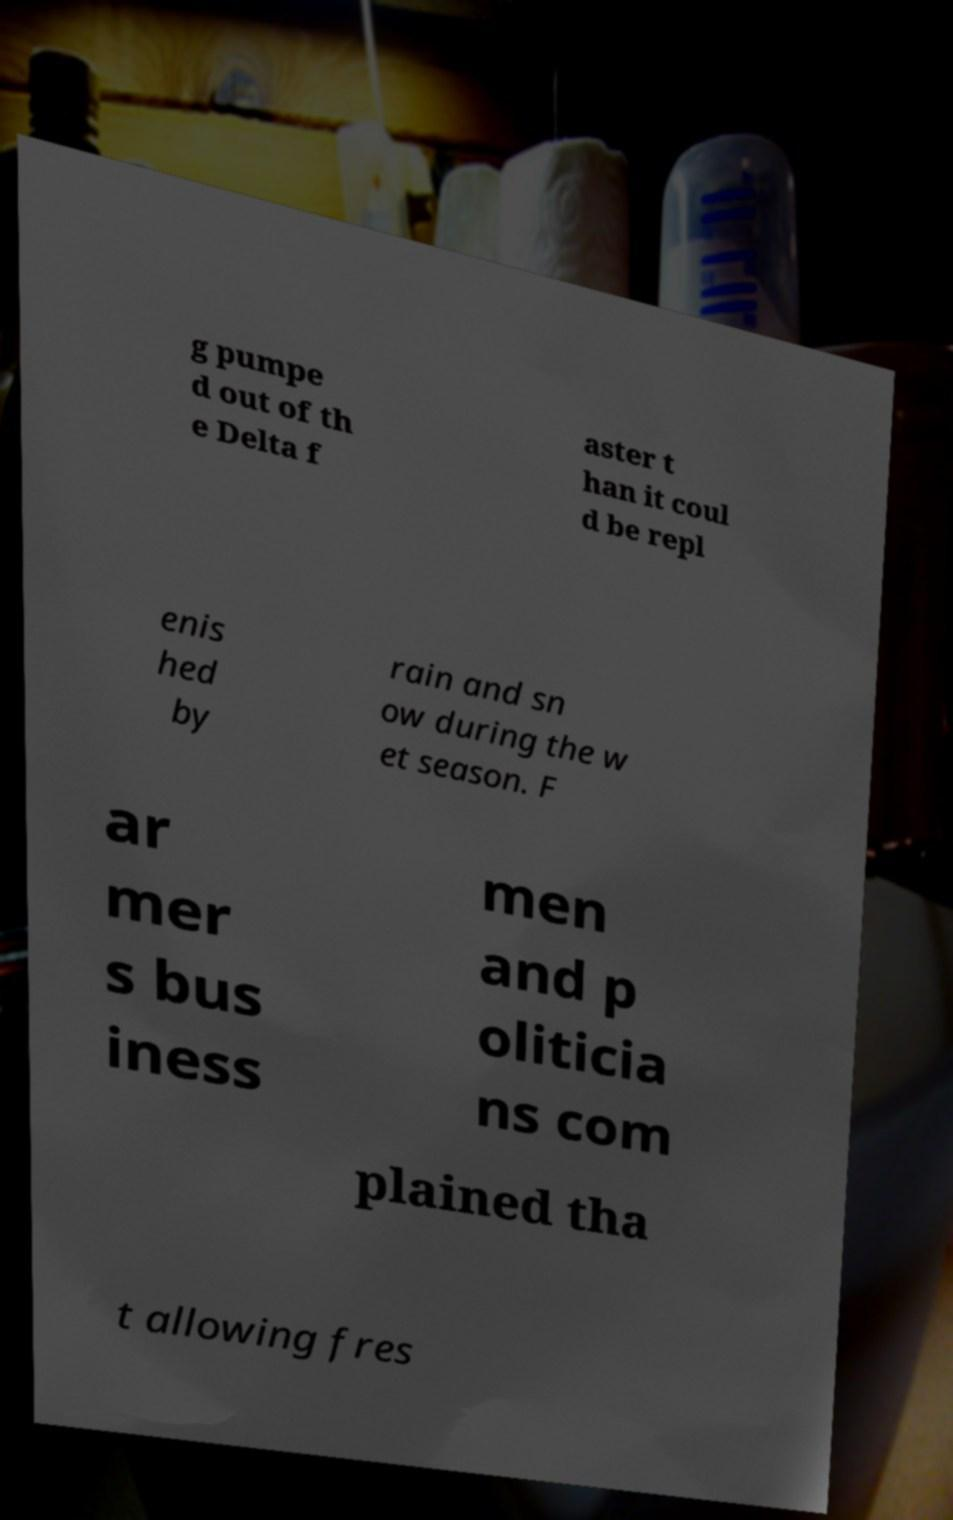I need the written content from this picture converted into text. Can you do that? g pumpe d out of th e Delta f aster t han it coul d be repl enis hed by rain and sn ow during the w et season. F ar mer s bus iness men and p oliticia ns com plained tha t allowing fres 